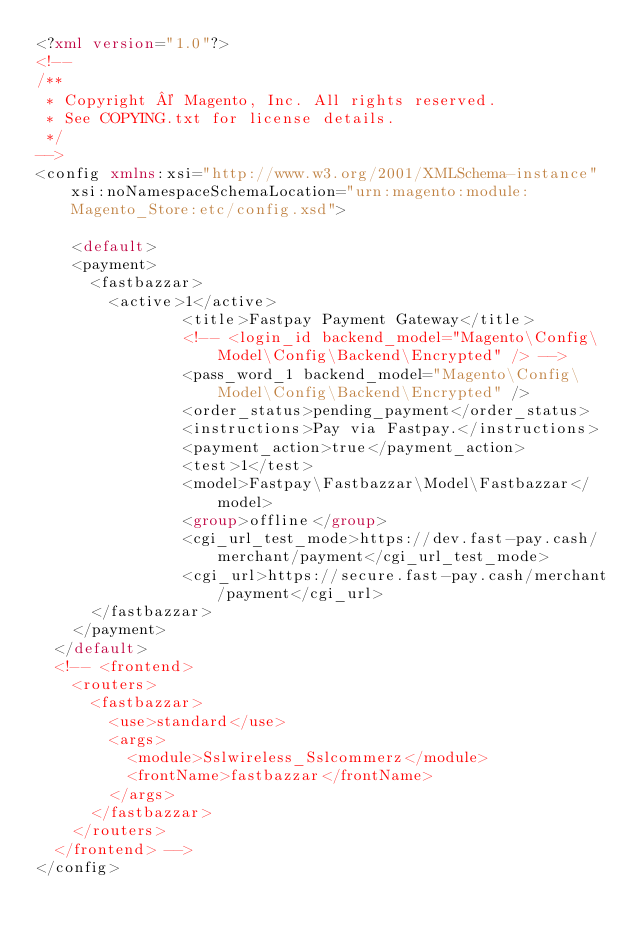Convert code to text. <code><loc_0><loc_0><loc_500><loc_500><_XML_><?xml version="1.0"?>
<!--
/**
 * Copyright © Magento, Inc. All rights reserved.
 * See COPYING.txt for license details.
 */
-->
<config xmlns:xsi="http://www.w3.org/2001/XMLSchema-instance" xsi:noNamespaceSchemaLocation="urn:magento:module:Magento_Store:etc/config.xsd">
      
    <default>
    <payment>
      <fastbazzar>
        <active>1</active>
                <title>Fastpay Payment Gateway</title>
                <!-- <login_id backend_model="Magento\Config\Model\Config\Backend\Encrypted" /> -->
                <pass_word_1 backend_model="Magento\Config\Model\Config\Backend\Encrypted" />
                <order_status>pending_payment</order_status>
                <instructions>Pay via Fastpay.</instructions>
                <payment_action>true</payment_action>
                <test>1</test>
                <model>Fastpay\Fastbazzar\Model\Fastbazzar</model>
                <group>offline</group>
                <cgi_url_test_mode>https://dev.fast-pay.cash/merchant/payment</cgi_url_test_mode>
                <cgi_url>https://secure.fast-pay.cash/merchant/payment</cgi_url>
      </fastbazzar>
    </payment>
  </default>
  <!-- <frontend>
    <routers>
      <fastbazzar>
        <use>standard</use>
        <args>
          <module>Sslwireless_Sslcommerz</module>
          <frontName>fastbazzar</frontName>
        </args>
      </fastbazzar>
    </routers>
  </frontend> -->
</config>
</code> 